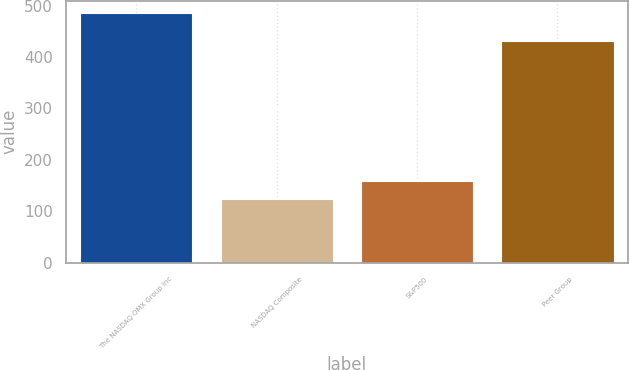Convert chart. <chart><loc_0><loc_0><loc_500><loc_500><bar_chart><fcel>The NASDAQ OMX Group Inc<fcel>NASDAQ Composite<fcel>S&P500<fcel>Peer Group<nl><fcel>485.2<fcel>123.71<fcel>159.86<fcel>431.54<nl></chart> 